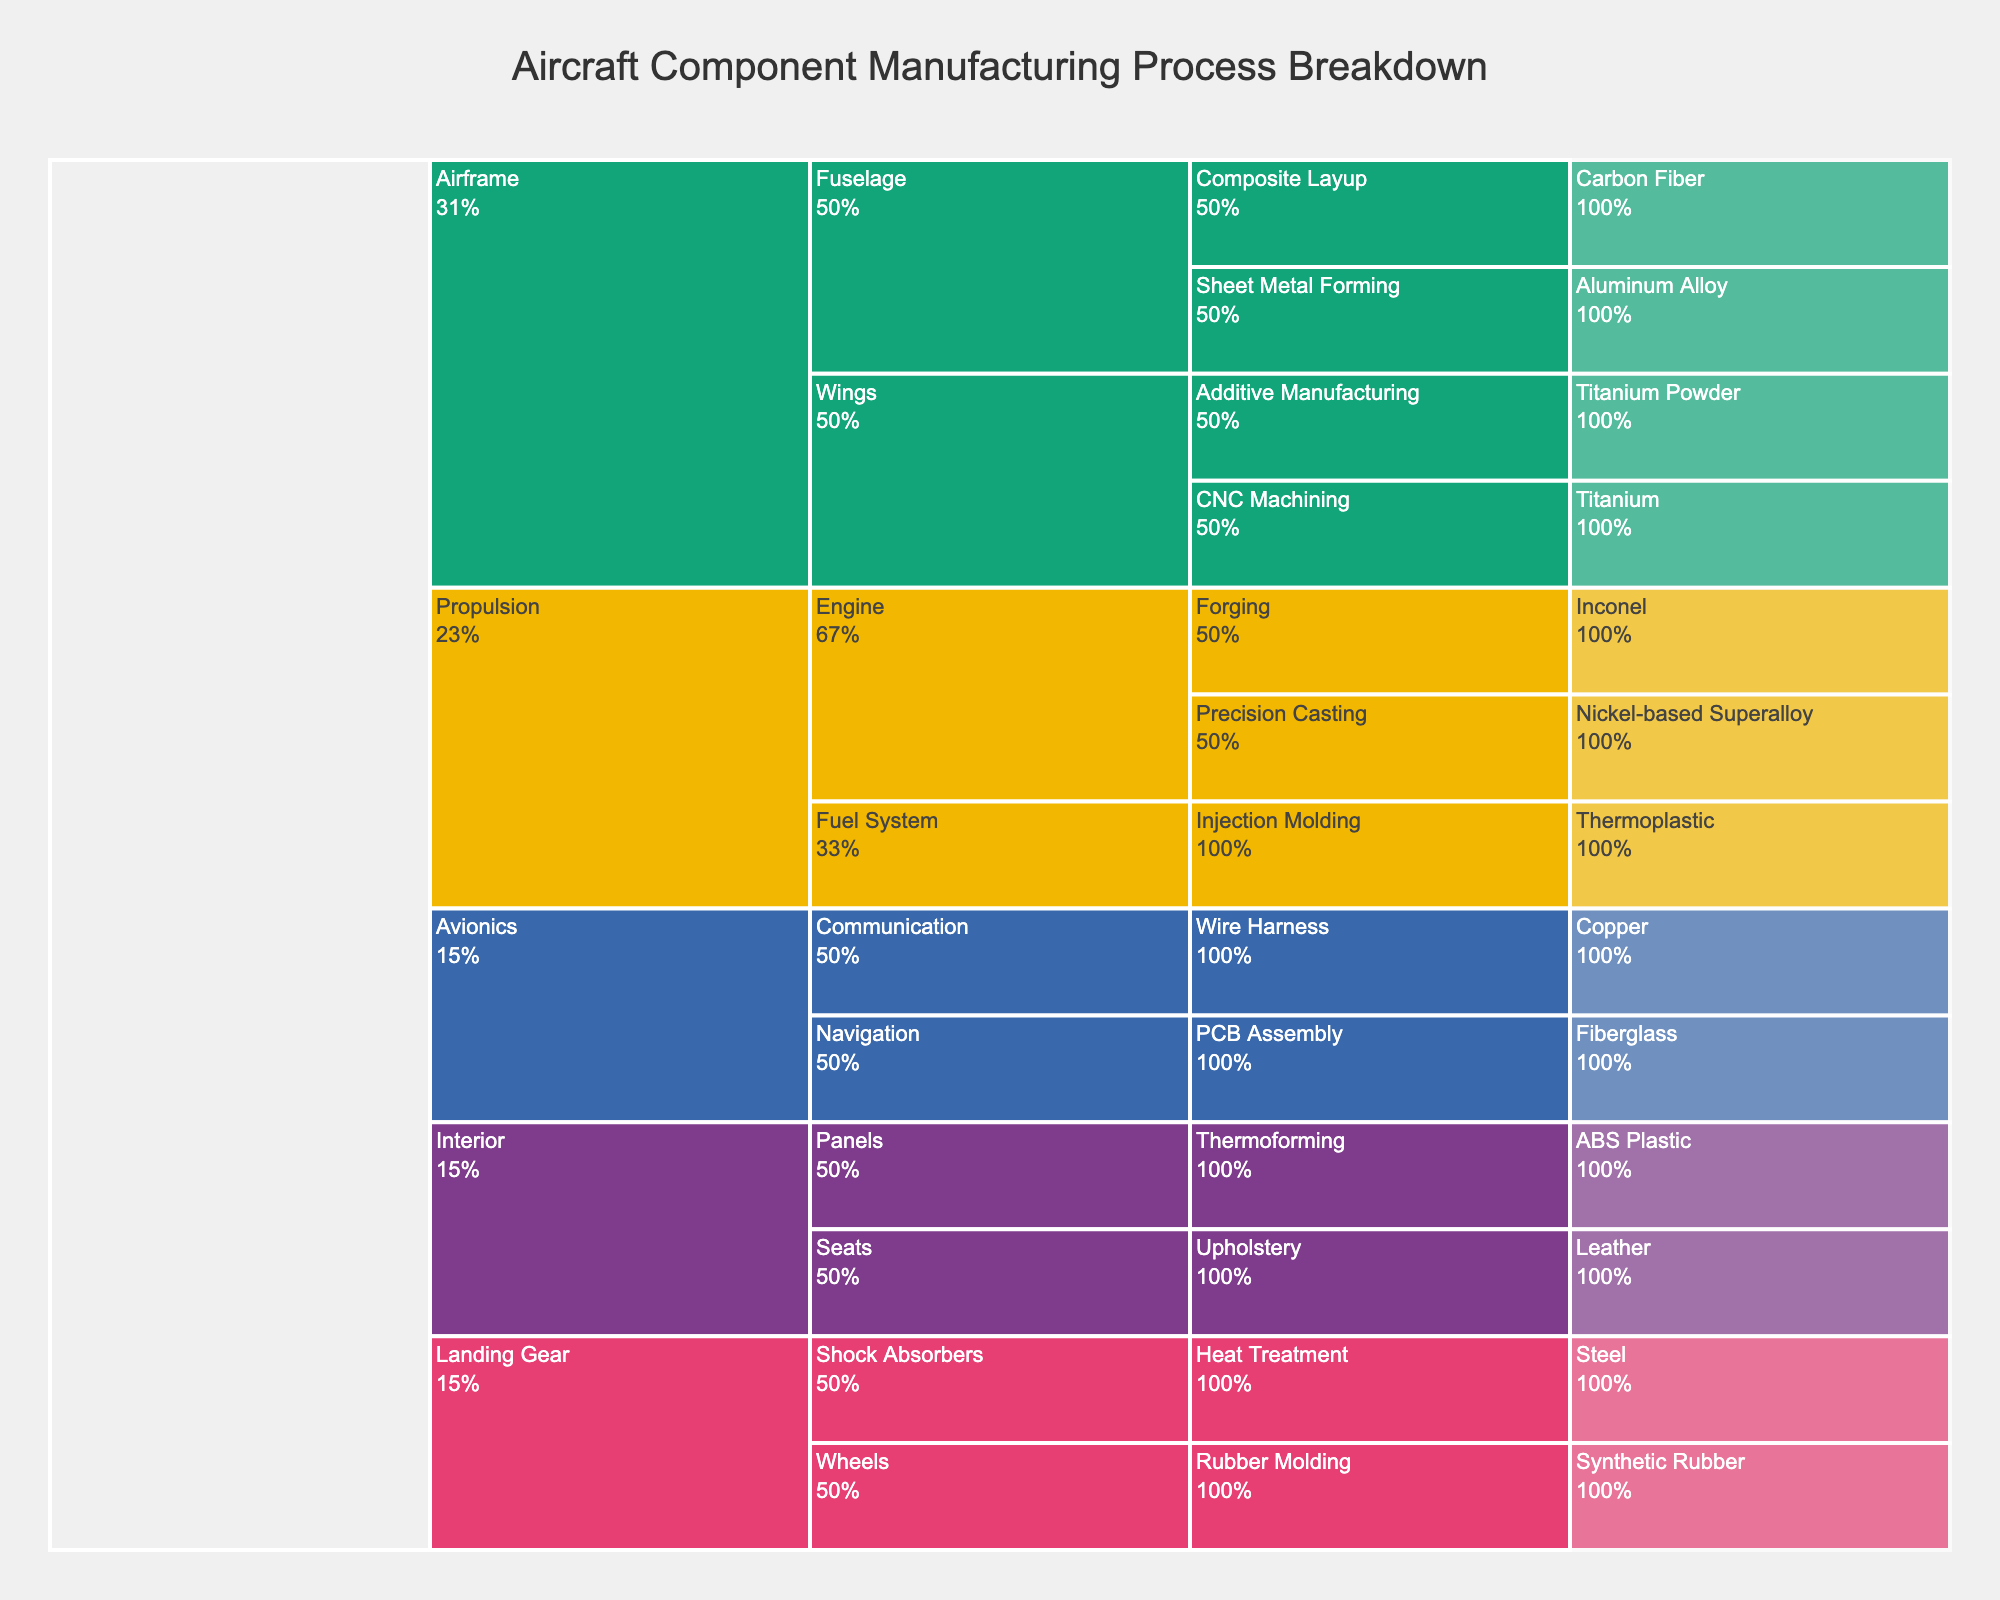What's the title of the figure? The title of the figure is usually displayed prominently at the top.
Answer: Aircraft Component Manufacturing Process Breakdown How many main stages are there in the aircraft component manufacturing process? There are multiple stages demonstrated by the top-level branches in the icicle chart. By counting them, we get five: Airframe, Propulsion, Avionics, Landing Gear, and Interior.
Answer: 5 Which stage has the highest number of sub-stages? By counting the sub-stages under each main stage, you can see that the 'Airframe' stage has the most sub-stages, which are Fuselage and Wings compared to other stages.
Answer: Airframe What material is used in the 'Fuselage' sub-stage of the 'Airframe' stage? Locate the 'Fuselage' sub-stage under 'Airframe' and see its child processes and their materials. The materials listed are Aluminum Alloy and Carbon Fiber.
Answer: Aluminum Alloy, Carbon Fiber How many different materials are used in the 'Propulsion' stage? Count the unique materials listed under each sub-stage of the 'Propulsion' stage. The materials are Nickel-based Superalloy, Inconel, and Thermoplastic.
Answer: 3 Which process uses 'Titanium' as a material? Scan through the chart to identify where 'Titanium' is mentioned. It's used in the 'CNC Machining' process under 'Wings' in 'Airframe' stage.
Answer: CNC Machining Compare the number of processes in 'Avionics' and 'Landing Gear' stages. Which has more? Count the number of processes under 'Avionics' (Navigation, Communication) and under 'Landing Gear' (Shock Absorbers, Wheels). Both have 2 processes each.
Answer: Equal What are the processes involved in the 'Seats' sub-stage of the 'Interior' stage? Locate the 'Seats' sub-stage and list the processes under it. There is one, which is Upholstery.
Answer: Upholstery Which stage involves the use of 'Leather'? Find where 'Leather' is listed as a material. It is used in the 'Seats' sub-stage of the 'Interior' stage.
Answer: Interior How many stages use 'Plastic' components? Identify the stages where materials like Thermoplastic or ABS Plastic are used. The stages are 'Propulsion' (Thermoplastic - Fuel System) and 'Interior' (ABS Plastic - Panels).
Answer: 2 